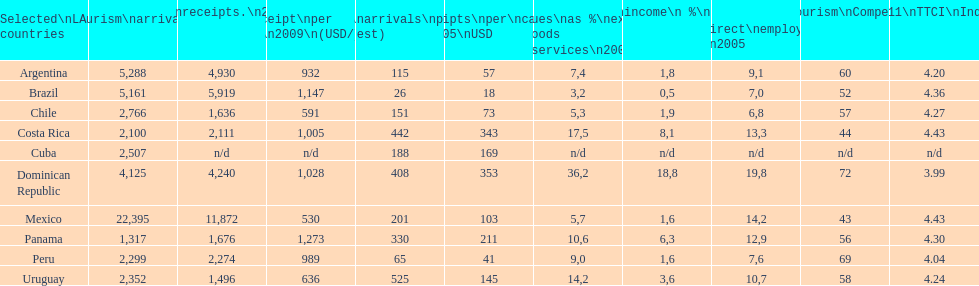Which latin american country had the largest number of tourism arrivals in 2010? Mexico. 